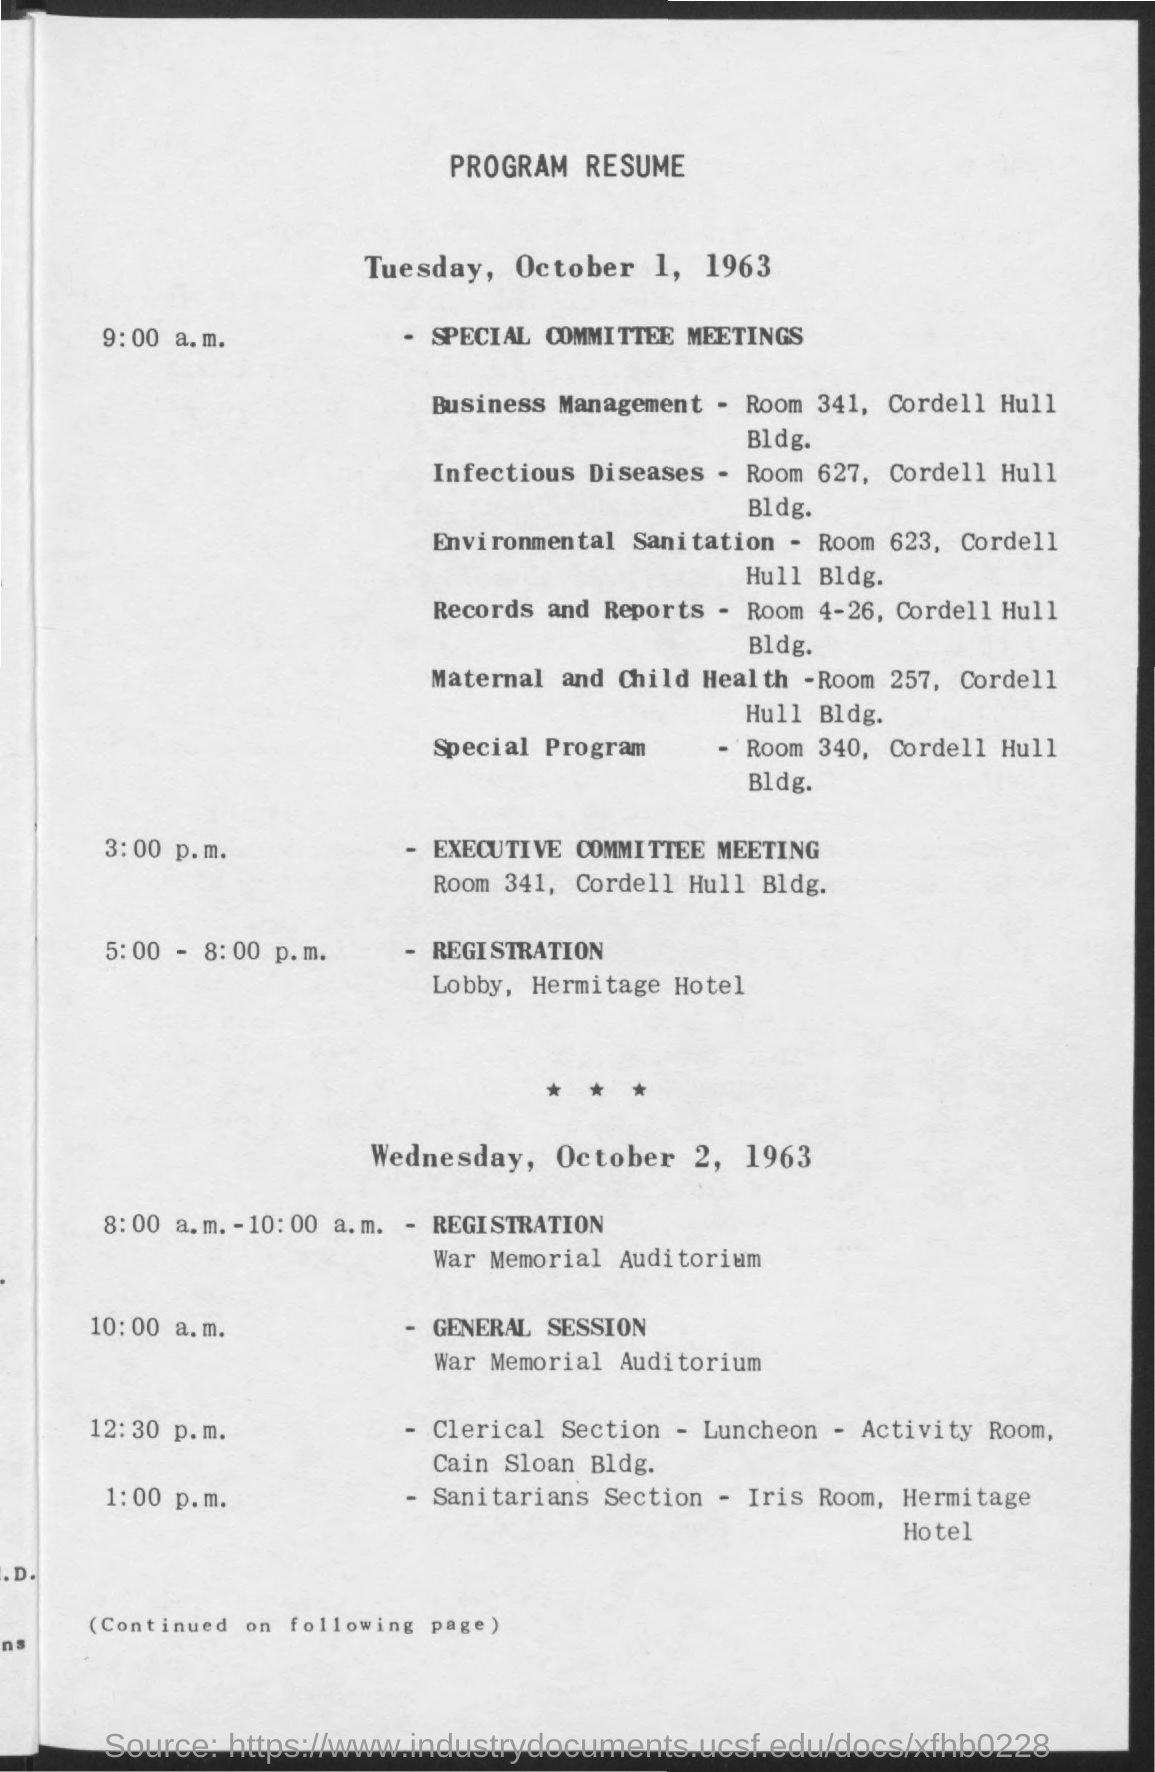Specify some key components in this picture. The title of the document is "Program Resume. 